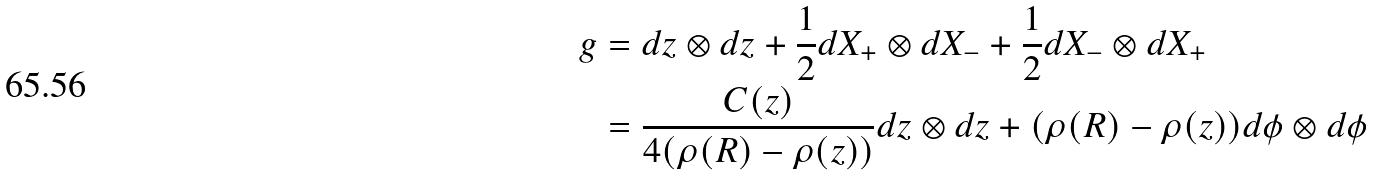<formula> <loc_0><loc_0><loc_500><loc_500>g & = d z \otimes d z + \frac { 1 } { 2 } d X _ { + } \otimes d X _ { - } + \frac { 1 } { 2 } d X _ { - } \otimes d X _ { + } \\ & = \frac { C ( z ) } { 4 ( \rho ( R ) - \rho ( z ) ) } d z \otimes d z + ( \rho ( R ) - \rho ( z ) ) d \phi \otimes d \phi</formula> 